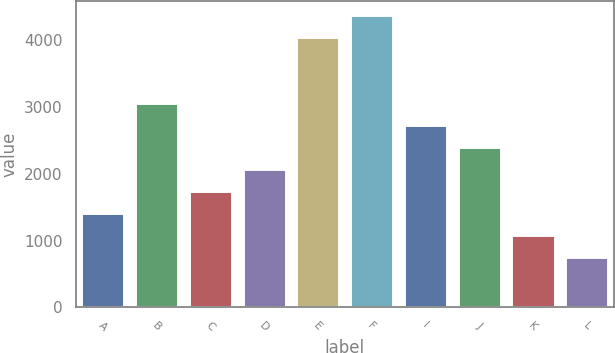<chart> <loc_0><loc_0><loc_500><loc_500><bar_chart><fcel>A<fcel>B<fcel>C<fcel>D<fcel>E<fcel>F<fcel>I<fcel>J<fcel>K<fcel>L<nl><fcel>1416.88<fcel>3059.08<fcel>1745.32<fcel>2073.76<fcel>4044.44<fcel>4372.88<fcel>2730.64<fcel>2402.2<fcel>1088.44<fcel>760<nl></chart> 